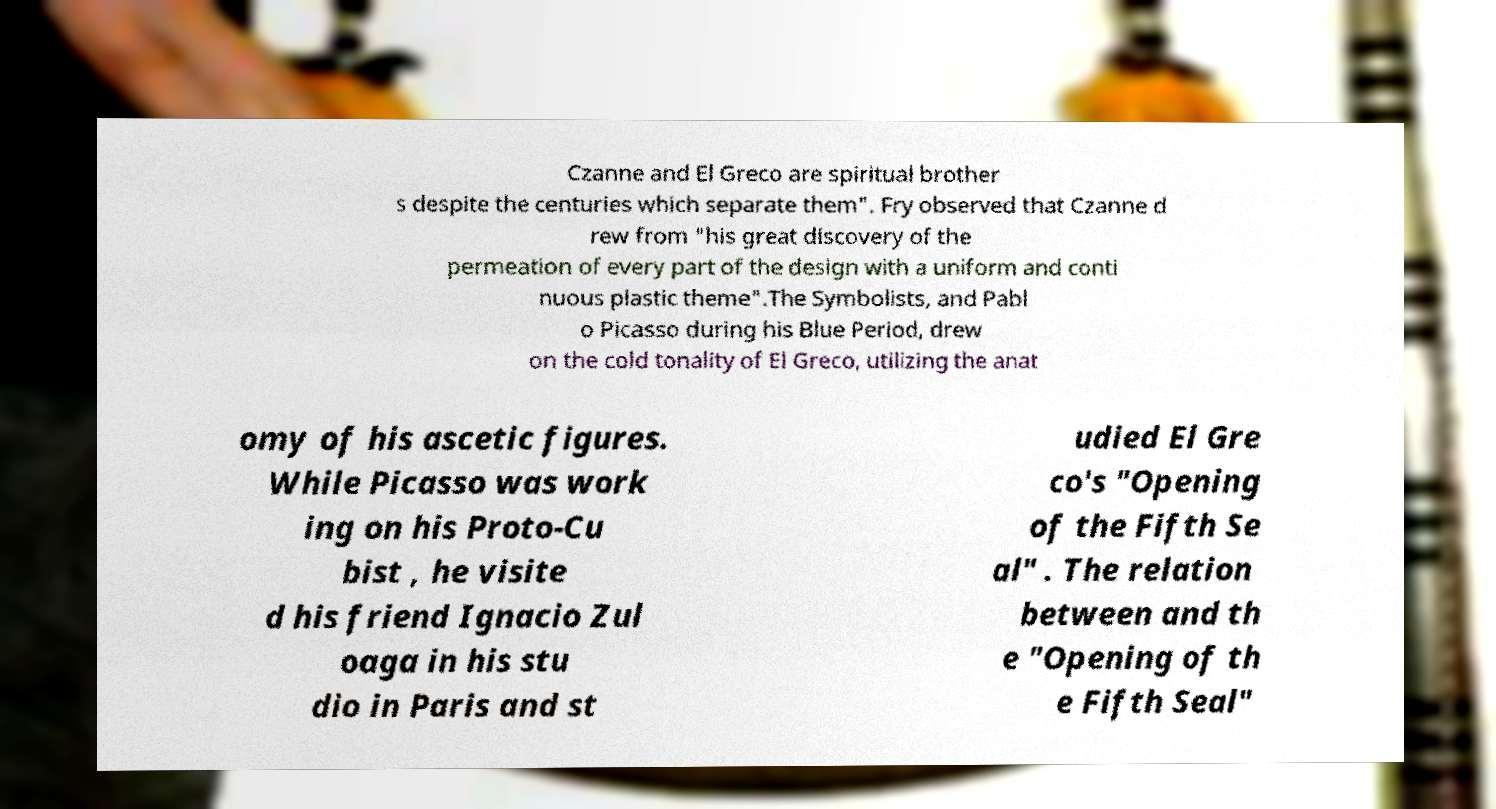Please identify and transcribe the text found in this image. Czanne and El Greco are spiritual brother s despite the centuries which separate them". Fry observed that Czanne d rew from "his great discovery of the permeation of every part of the design with a uniform and conti nuous plastic theme".The Symbolists, and Pabl o Picasso during his Blue Period, drew on the cold tonality of El Greco, utilizing the anat omy of his ascetic figures. While Picasso was work ing on his Proto-Cu bist , he visite d his friend Ignacio Zul oaga in his stu dio in Paris and st udied El Gre co's "Opening of the Fifth Se al" . The relation between and th e "Opening of th e Fifth Seal" 